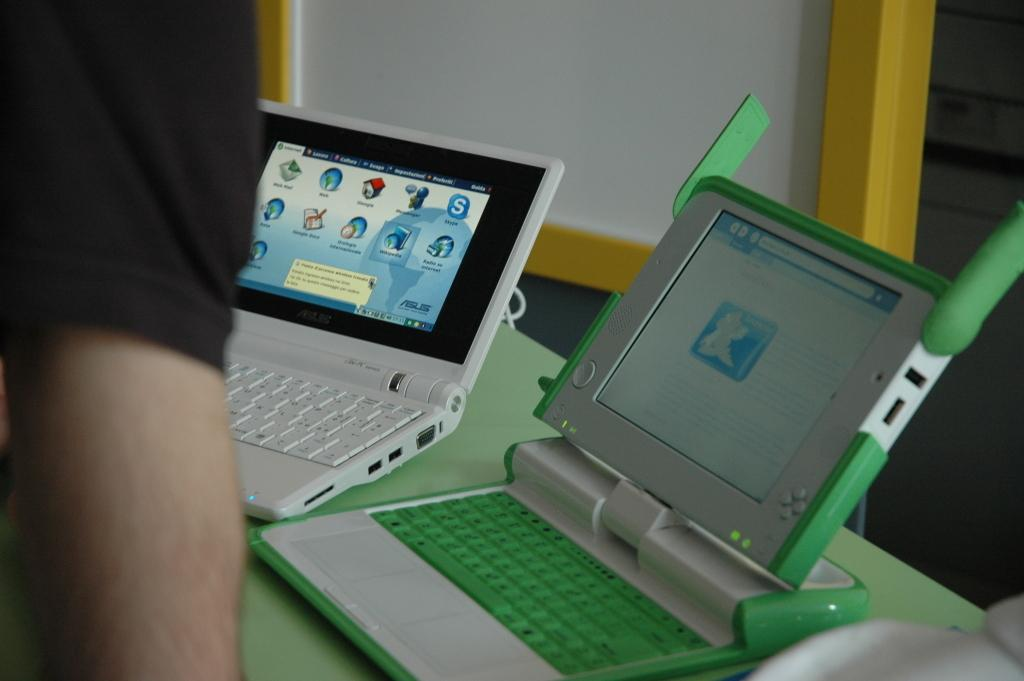What is the main subject of the image? There is a person in the image. What objects can be seen on the table in the image? There are gaming laptops on a table in the image. Where is the scarecrow located in the image? There is no scarecrow present in the image. How fast is the snail moving in the image? There is no snail present in the image, so its speed cannot be determined. 